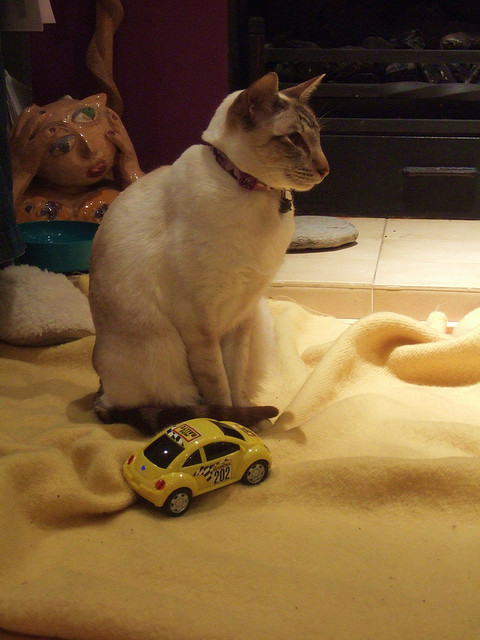<image>Who is this a bust of? I don't know who this is a bust of. It might be a cat. Who is this a bust of? I am not sure who this bust is of. It could be a cat or someone else. 